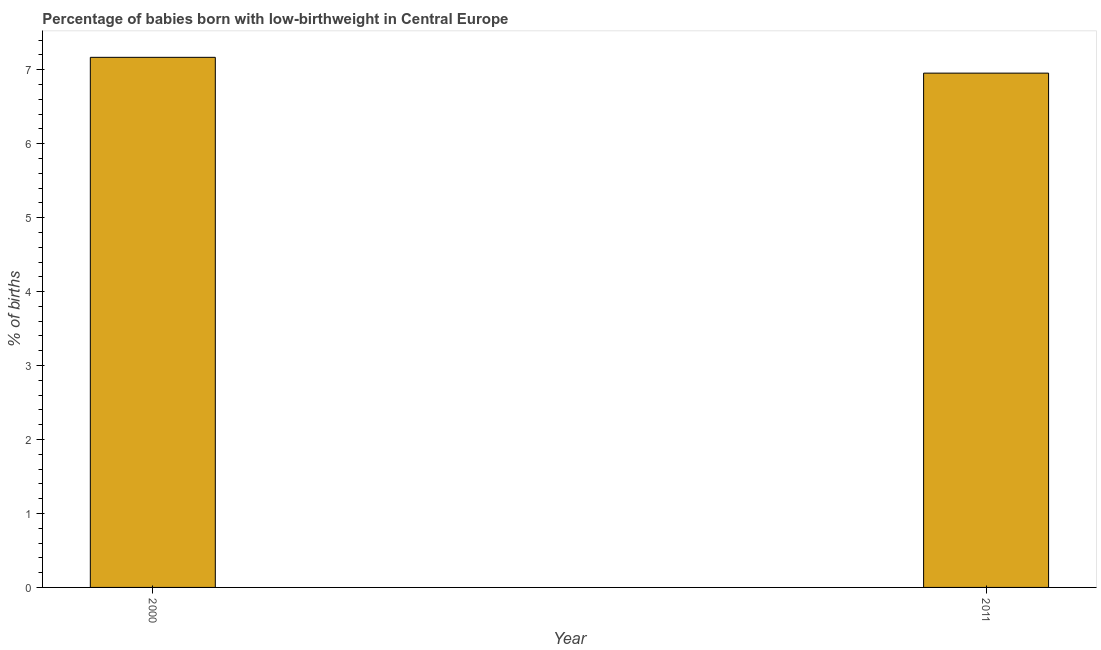Does the graph contain grids?
Keep it short and to the point. No. What is the title of the graph?
Ensure brevity in your answer.  Percentage of babies born with low-birthweight in Central Europe. What is the label or title of the X-axis?
Provide a short and direct response. Year. What is the label or title of the Y-axis?
Your answer should be very brief. % of births. What is the percentage of babies who were born with low-birthweight in 2000?
Your answer should be compact. 7.17. Across all years, what is the maximum percentage of babies who were born with low-birthweight?
Provide a succinct answer. 7.17. Across all years, what is the minimum percentage of babies who were born with low-birthweight?
Your answer should be very brief. 6.95. In which year was the percentage of babies who were born with low-birthweight maximum?
Offer a very short reply. 2000. What is the sum of the percentage of babies who were born with low-birthweight?
Provide a succinct answer. 14.12. What is the difference between the percentage of babies who were born with low-birthweight in 2000 and 2011?
Offer a very short reply. 0.21. What is the average percentage of babies who were born with low-birthweight per year?
Make the answer very short. 7.06. What is the median percentage of babies who were born with low-birthweight?
Your answer should be very brief. 7.06. In how many years, is the percentage of babies who were born with low-birthweight greater than 5.4 %?
Your response must be concise. 2. Do a majority of the years between 2000 and 2011 (inclusive) have percentage of babies who were born with low-birthweight greater than 1.2 %?
Provide a succinct answer. Yes. What is the ratio of the percentage of babies who were born with low-birthweight in 2000 to that in 2011?
Your answer should be compact. 1.03. In how many years, is the percentage of babies who were born with low-birthweight greater than the average percentage of babies who were born with low-birthweight taken over all years?
Offer a terse response. 1. How many bars are there?
Offer a terse response. 2. How many years are there in the graph?
Keep it short and to the point. 2. What is the % of births in 2000?
Provide a short and direct response. 7.17. What is the % of births of 2011?
Offer a terse response. 6.95. What is the difference between the % of births in 2000 and 2011?
Make the answer very short. 0.21. What is the ratio of the % of births in 2000 to that in 2011?
Your answer should be very brief. 1.03. 